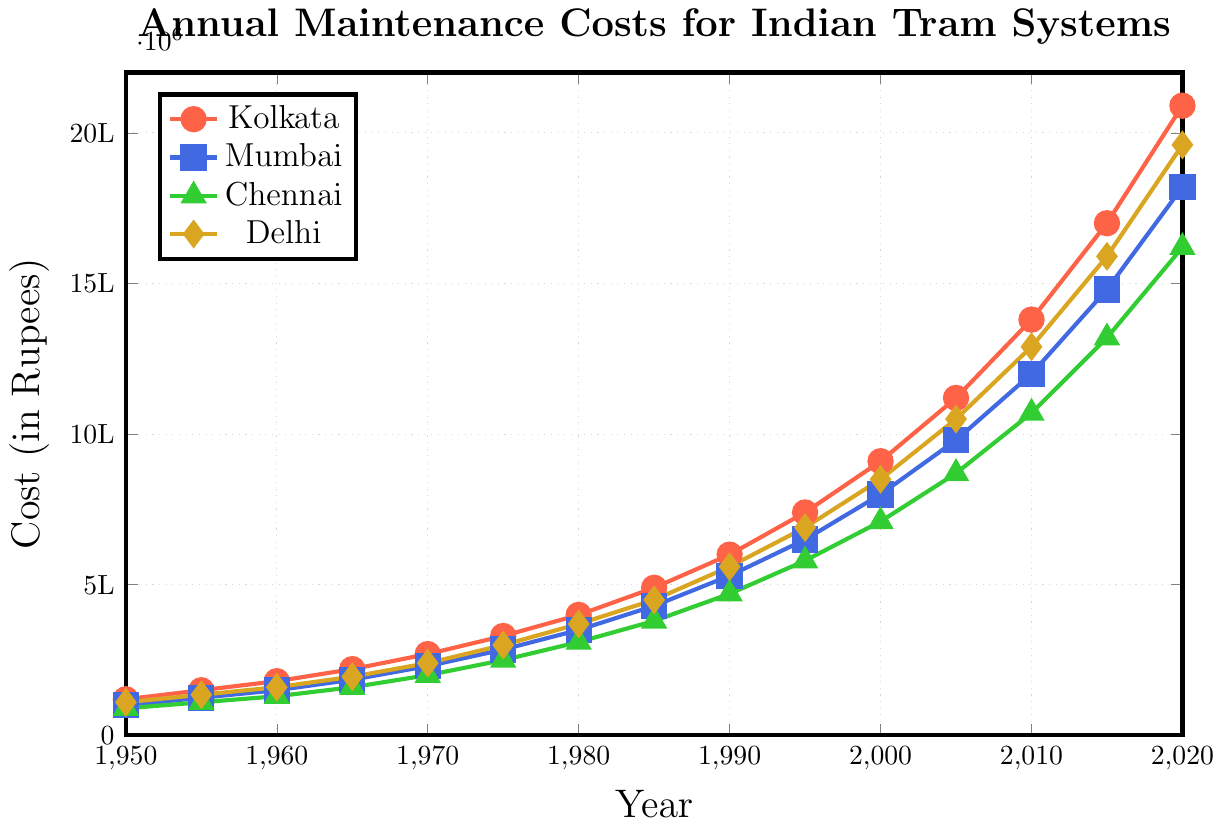What is the total maintenance cost for Kolkata in 1965 and 1970? To find the total maintenance cost for Kolkata in 1965 and 1970, identify the values for those years on the plot and sum them. From the plot, Kolkata's costs are 220,000 in 1965 and 270,000 in 1970. Adding these gives 220,000 + 270,000 = 490,000.
Answer: 490,000 Which city had the highest increase in maintenance costs from 1980 to 1985? To determine the highest increase, find the maintenance costs for each city in 1980 and 1985, then calculate the difference for each. Kolkata: 490,000 - 400,000 = 90,000; Mumbai: 430,000 - 350,000 = 80,000; Chennai: 380,000 - 310,000 = 70,000; Delhi: 450,000 - 370,000 = 80,000. Therefore, Kolkata had the highest increase.
Answer: Kolkata When did Delhi's maintenance costs first exceed 1 million rupees? Look at the trend for Delhi's maintenance costs on the plot and identify the year they first exceed 1 million. From the plot, Delhi's costs are above 1 million starting from the year 2000.
Answer: 2000 Which city had the lowest maintenance costs in 1950, and what were they? Identify and compare the maintenance costs for all cities in 1950. From the plot, Chennai had the lowest maintenance cost with 90,000 rupees in 1950.
Answer: Chennai, 90,000 What was the average maintenance cost for Mumbai between 1960 and 1970? To find the average, add Mumbai's maintenance costs for 1960, 1965, and 1970 and divide by 3. These values are 150,000 (1960), 185,000 (1965), and 230,000 (1970). The sum is 565,000, and dividing by 3 gives an average of 188,333.33.
Answer: 188,333.33 By how much did the maintenance cost for Chennai increase from 2010 to 2020? Find the difference in costs for Chennai between 2010 and 2020. From the plot, the costs are 1,070,000 in 2010 and 1,620,000 in 2020. The increase is 1,620,000 - 1,070,000 = 550,000.
Answer: 550,000 In what year did Kolkata surpass 1 million rupees in maintenance costs? Observe the trend for Kolkata's maintenance costs and identify the year they surpass 1 million rupees. From the plot, the year is 2005.
Answer: 2005 What color is used to represent the maintenance costs for Delhi? Based on the legend in the plot, identify the color associated with Delhi. The color used for Delhi is gold.
Answer: Gold 